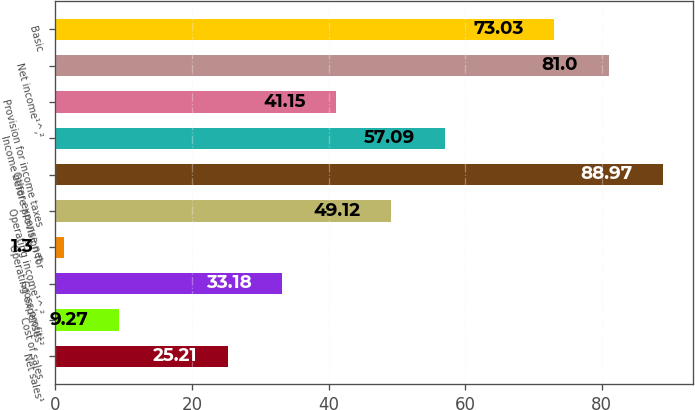<chart> <loc_0><loc_0><loc_500><loc_500><bar_chart><fcel>Net sales¹<fcel>Cost of sales<fcel>Gross profit¹<fcel>Operating expenses²<fcel>Operating income¹^‚²<fcel>Other expense net<fcel>Income before provision for<fcel>Provision for income taxes<fcel>Net income¹^‚²<fcel>Basic<nl><fcel>25.21<fcel>9.27<fcel>33.18<fcel>1.3<fcel>49.12<fcel>88.97<fcel>57.09<fcel>41.15<fcel>81<fcel>73.03<nl></chart> 